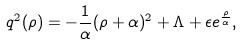<formula> <loc_0><loc_0><loc_500><loc_500>q ^ { 2 } ( \rho ) = - \frac { 1 } { \alpha } ( \rho + \alpha ) ^ { 2 } + \Lambda + \epsilon e ^ { \frac { \rho } { \alpha } } ,</formula> 